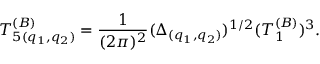Convert formula to latex. <formula><loc_0><loc_0><loc_500><loc_500>T _ { 5 ( q _ { 1 } , q _ { 2 } ) } ^ { ( B ) } = { \frac { 1 } { ( 2 \pi ) ^ { 2 } } } ( \Delta _ { ( q _ { 1 } , q _ { 2 } ) } ) ^ { 1 / 2 } ( T _ { 1 } ^ { ( B ) } ) ^ { 3 } .</formula> 